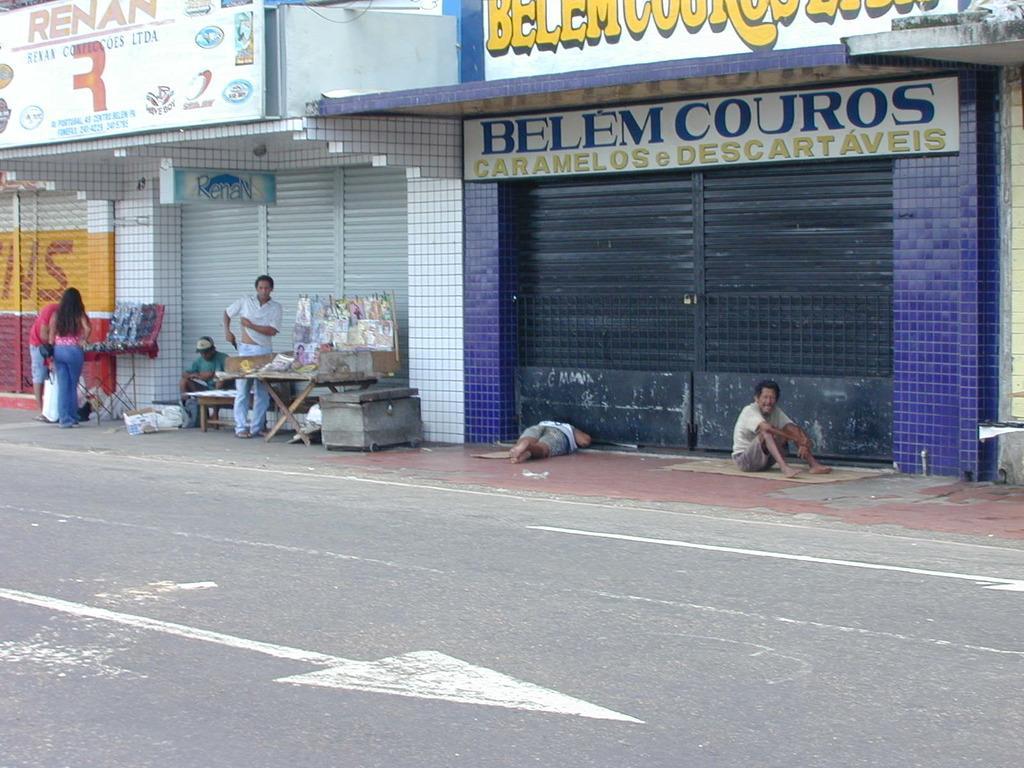Please provide a concise description of this image. In the foreground I can see six persons on the road, bench, table, box and boards. In the background I can see buildings. This image is taken during a day on the road. 